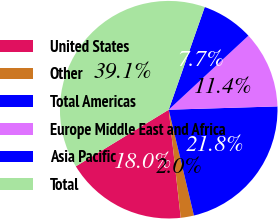<chart> <loc_0><loc_0><loc_500><loc_500><pie_chart><fcel>United States<fcel>Other<fcel>Total Americas<fcel>Europe Middle East and Africa<fcel>Asia Pacific<fcel>Total<nl><fcel>18.05%<fcel>1.96%<fcel>21.76%<fcel>11.43%<fcel>7.72%<fcel>39.08%<nl></chart> 